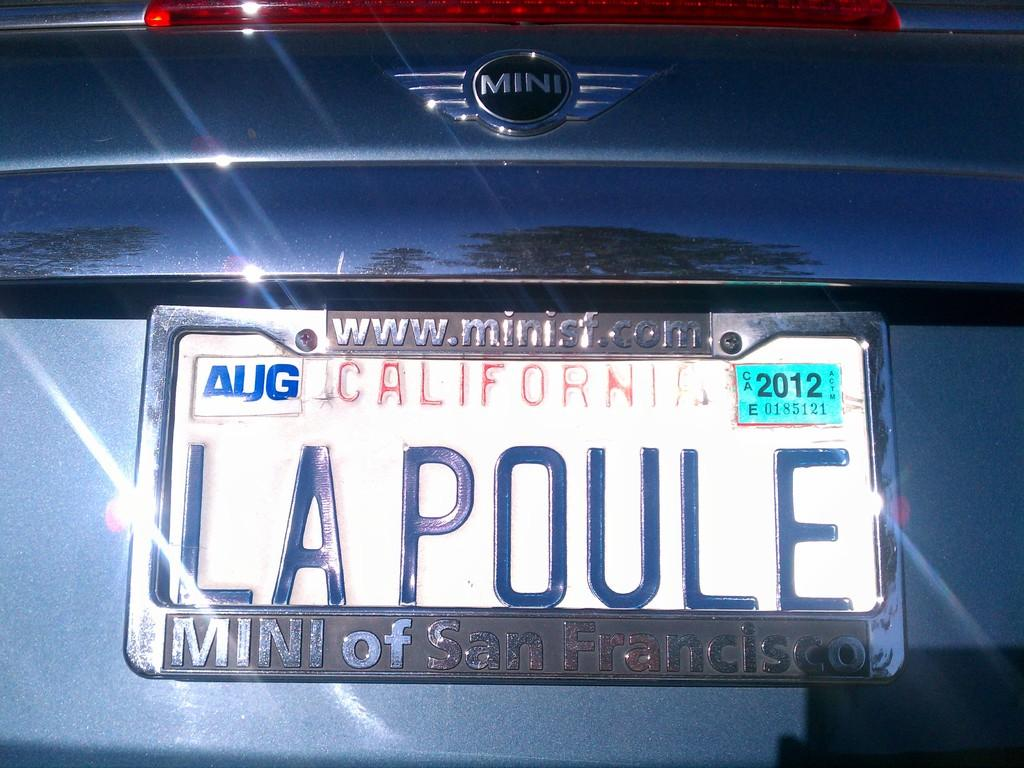<image>
Render a clear and concise summary of the photo. A California tag which reads LA POULE. on a Mini Cooper. 